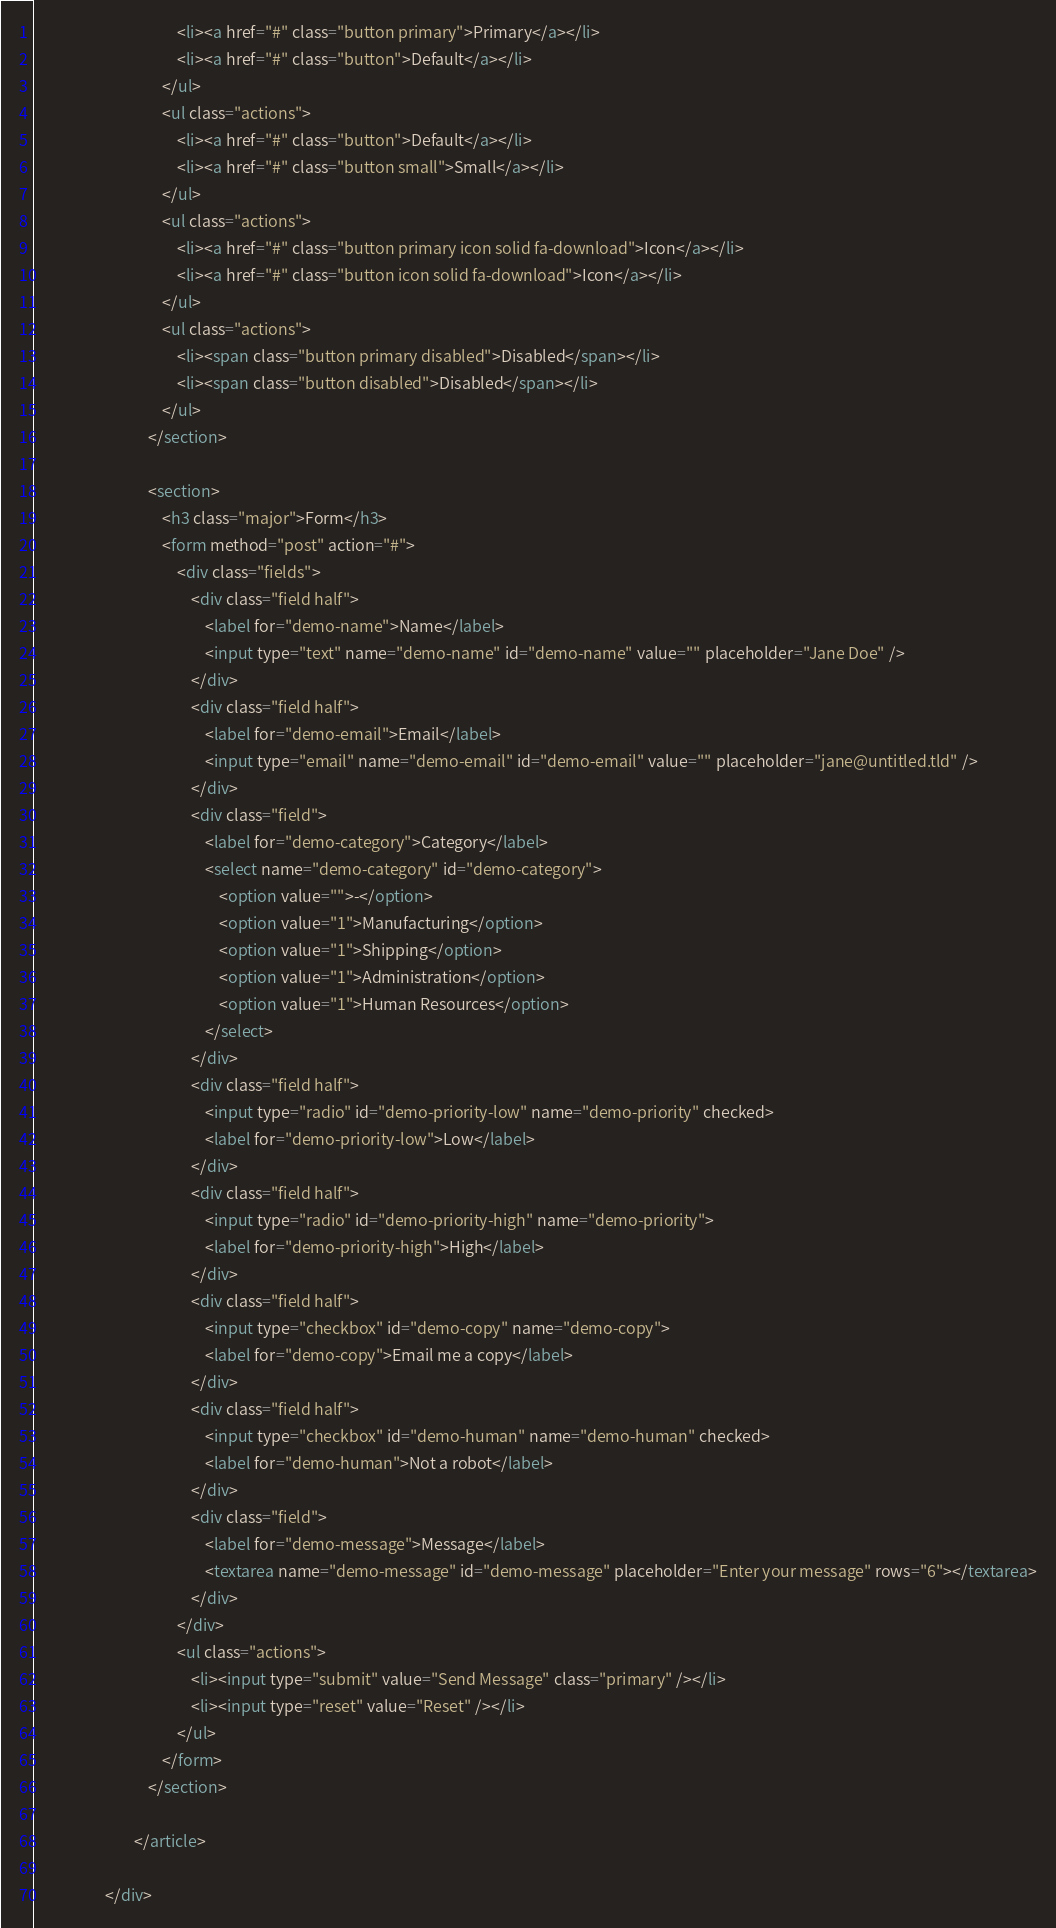<code> <loc_0><loc_0><loc_500><loc_500><_HTML_>										<li><a href="#" class="button primary">Primary</a></li>
										<li><a href="#" class="button">Default</a></li>
									</ul>
									<ul class="actions">
										<li><a href="#" class="button">Default</a></li>
										<li><a href="#" class="button small">Small</a></li>
									</ul>
									<ul class="actions">
										<li><a href="#" class="button primary icon solid fa-download">Icon</a></li>
										<li><a href="#" class="button icon solid fa-download">Icon</a></li>
									</ul>
									<ul class="actions">
										<li><span class="button primary disabled">Disabled</span></li>
										<li><span class="button disabled">Disabled</span></li>
									</ul>
								</section>

								<section>
									<h3 class="major">Form</h3>
									<form method="post" action="#">
										<div class="fields">
											<div class="field half">
												<label for="demo-name">Name</label>
												<input type="text" name="demo-name" id="demo-name" value="" placeholder="Jane Doe" />
											</div>
											<div class="field half">
												<label for="demo-email">Email</label>
												<input type="email" name="demo-email" id="demo-email" value="" placeholder="jane@untitled.tld" />
											</div>
											<div class="field">
												<label for="demo-category">Category</label>
												<select name="demo-category" id="demo-category">
													<option value="">-</option>
													<option value="1">Manufacturing</option>
													<option value="1">Shipping</option>
													<option value="1">Administration</option>
													<option value="1">Human Resources</option>
												</select>
											</div>
											<div class="field half">
												<input type="radio" id="demo-priority-low" name="demo-priority" checked>
												<label for="demo-priority-low">Low</label>
											</div>
											<div class="field half">
												<input type="radio" id="demo-priority-high" name="demo-priority">
												<label for="demo-priority-high">High</label>
											</div>
											<div class="field half">
												<input type="checkbox" id="demo-copy" name="demo-copy">
												<label for="demo-copy">Email me a copy</label>
											</div>
											<div class="field half">
												<input type="checkbox" id="demo-human" name="demo-human" checked>
												<label for="demo-human">Not a robot</label>
											</div>
											<div class="field">
												<label for="demo-message">Message</label>
												<textarea name="demo-message" id="demo-message" placeholder="Enter your message" rows="6"></textarea>
											</div>
										</div>
										<ul class="actions">
											<li><input type="submit" value="Send Message" class="primary" /></li>
											<li><input type="reset" value="Reset" /></li>
										</ul>
									</form>
								</section>

							</article>

					</div>
</code> 